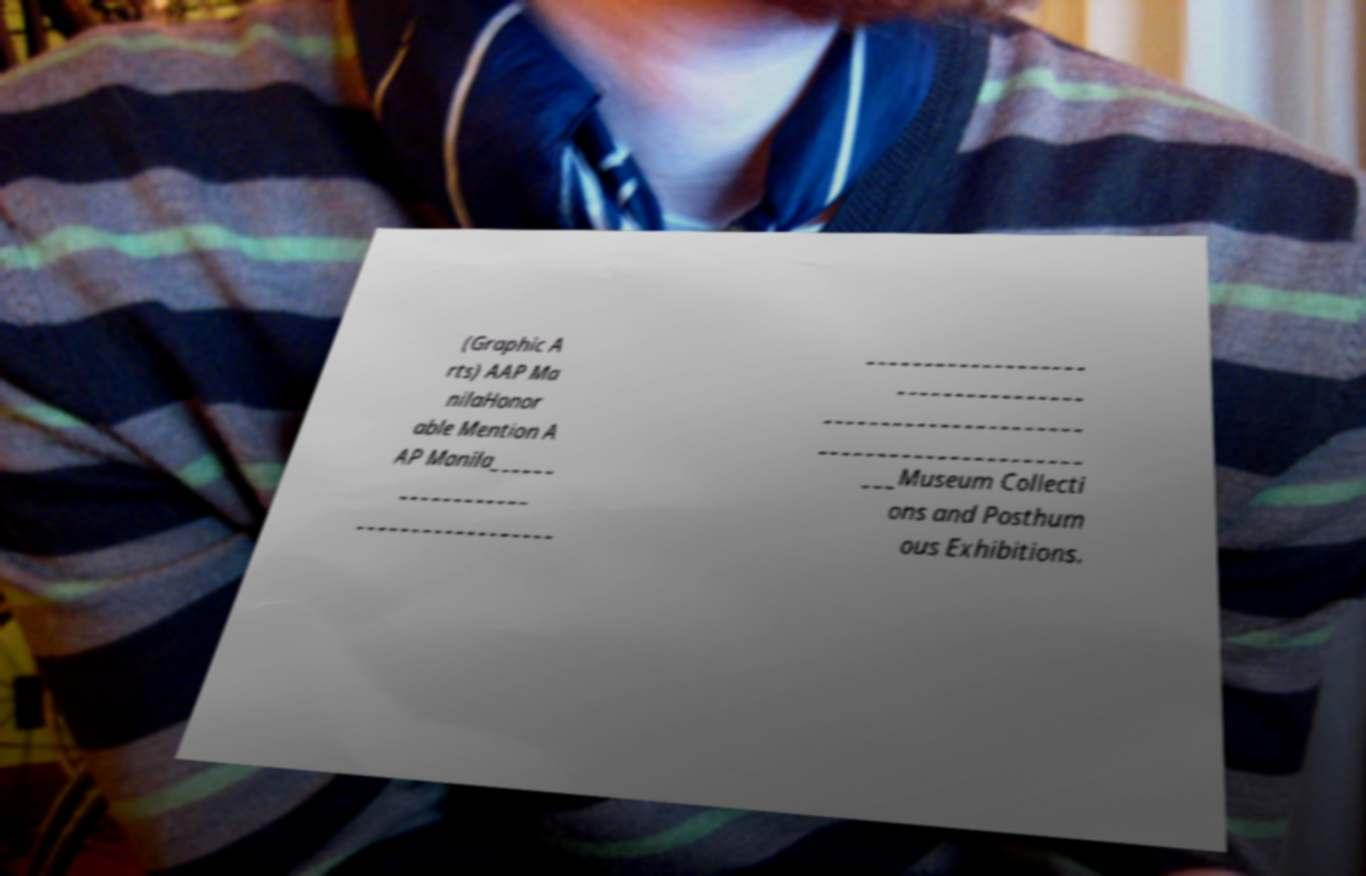What messages or text are displayed in this image? I need them in a readable, typed format. (Graphic A rts) AAP Ma nilaHonor able Mention A AP Manila______ ____________ __________________ ___________________ ________________ ______________________ ______________________ ___Museum Collecti ons and Posthum ous Exhibitions. 